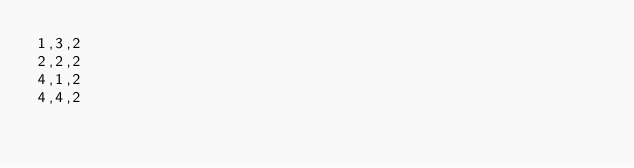Convert code to text. <code><loc_0><loc_0><loc_500><loc_500><_C_>1,3,2
2,2,2
4,1,2
4,4,2
</code> 